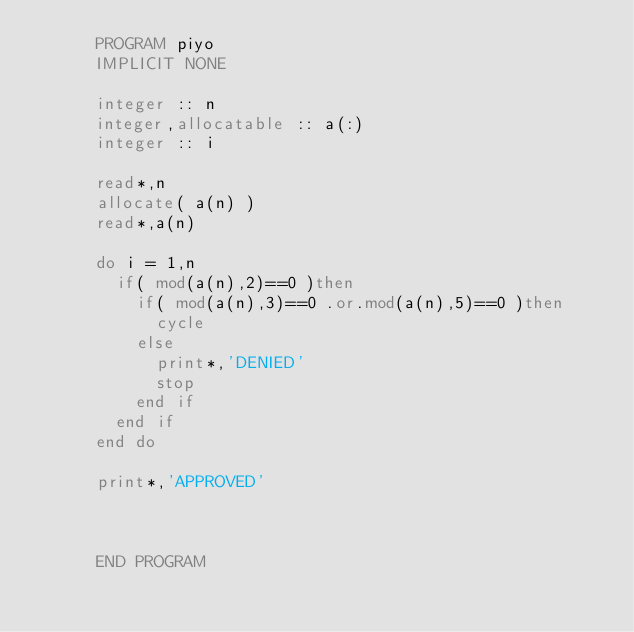<code> <loc_0><loc_0><loc_500><loc_500><_FORTRAN_>      PROGRAM piyo
      IMPLICIT NONE
      
      integer :: n
      integer,allocatable :: a(:)
      integer :: i
      
      read*,n
      allocate( a(n) )
      read*,a(n)
      
      do i = 1,n
        if( mod(a(n),2)==0 )then
          if( mod(a(n),3)==0 .or.mod(a(n),5)==0 )then
            cycle
          else
            print*,'DENIED'
            stop
          end if
        end if
      end do
      
      print*,'APPROVED'
      
      
      
      END PROGRAM</code> 